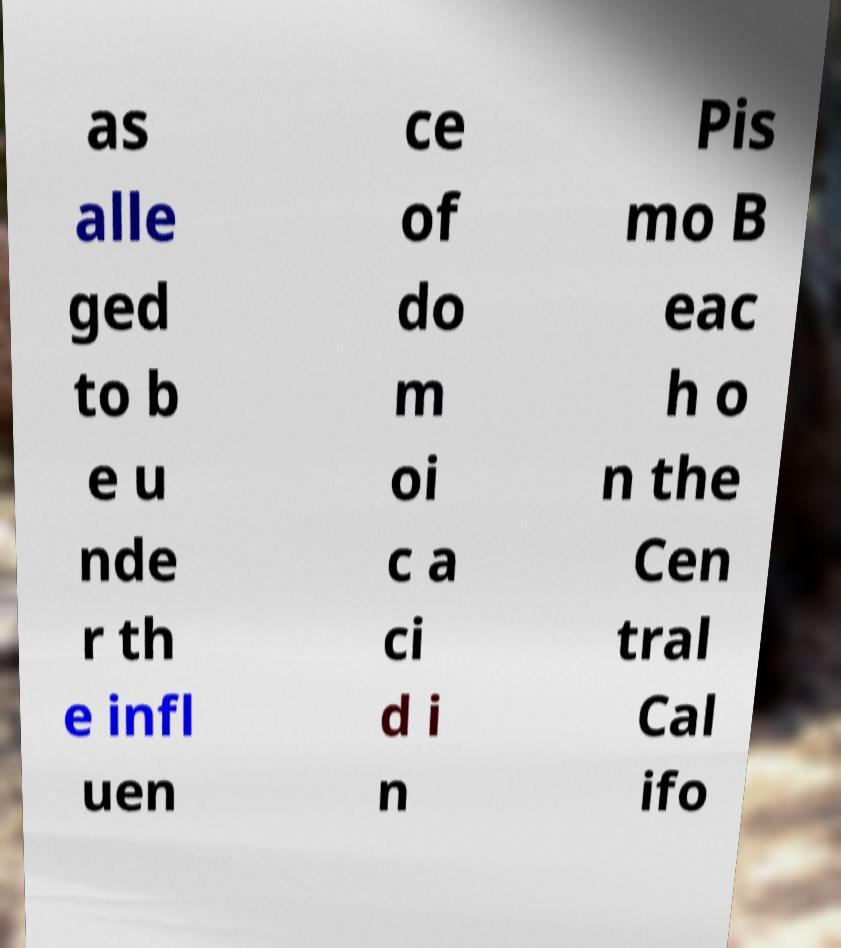Can you read and provide the text displayed in the image?This photo seems to have some interesting text. Can you extract and type it out for me? as alle ged to b e u nde r th e infl uen ce of do m oi c a ci d i n Pis mo B eac h o n the Cen tral Cal ifo 